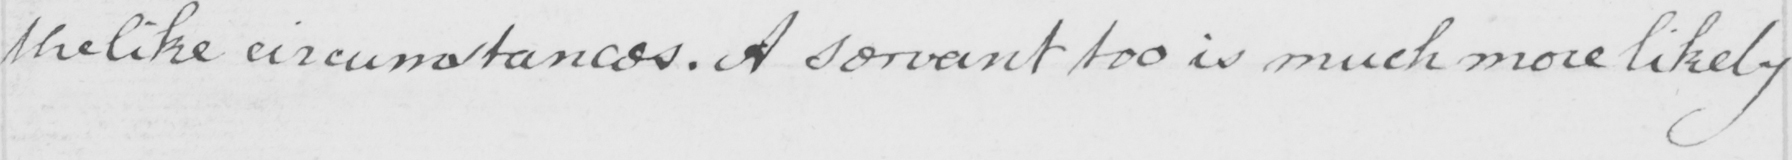Transcribe the text shown in this historical manuscript line. the like circumstances . A servant is much more likely 